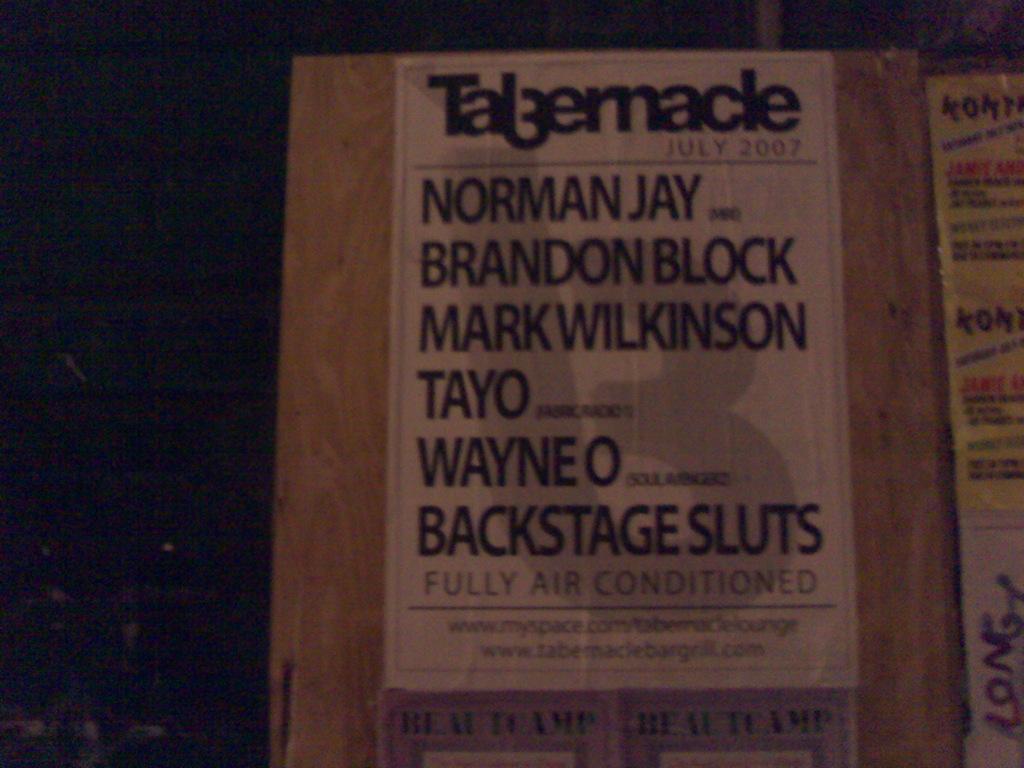Please provide a concise description of this image. In this image I can see the brown colored board and a white colored poster attached to it. I can see few words written on it. I can see the black colored background. 